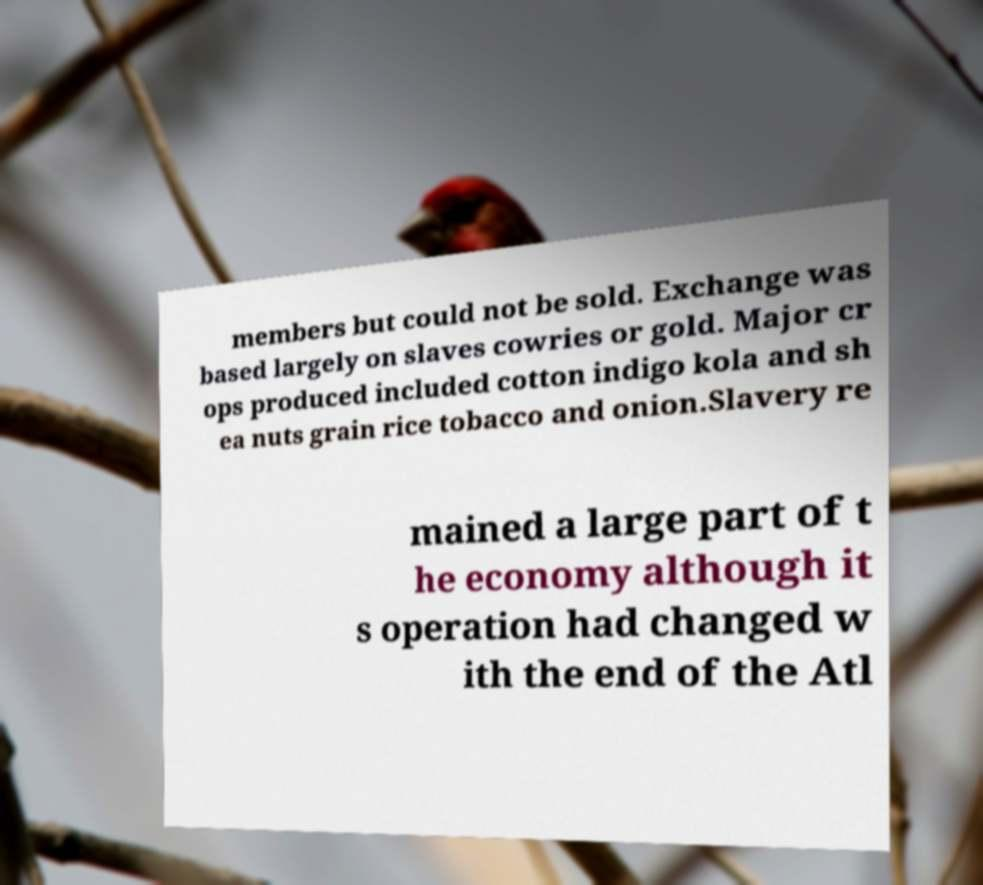There's text embedded in this image that I need extracted. Can you transcribe it verbatim? members but could not be sold. Exchange was based largely on slaves cowries or gold. Major cr ops produced included cotton indigo kola and sh ea nuts grain rice tobacco and onion.Slavery re mained a large part of t he economy although it s operation had changed w ith the end of the Atl 